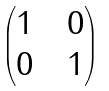<formula> <loc_0><loc_0><loc_500><loc_500>\begin{pmatrix} 1 & & 0 \\ 0 & & 1 \end{pmatrix}</formula> 